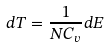<formula> <loc_0><loc_0><loc_500><loc_500>d T = \frac { 1 } { N C _ { v } } d E</formula> 